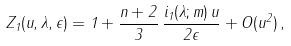<formula> <loc_0><loc_0><loc_500><loc_500>Z _ { 1 } ( u , \lambda , \epsilon ) = 1 + \frac { n + 2 } { 3 } \, \frac { i _ { 1 } ( \lambda ; m ) \, u } { 2 \epsilon } + O ( u ^ { 2 } ) \, ,</formula> 